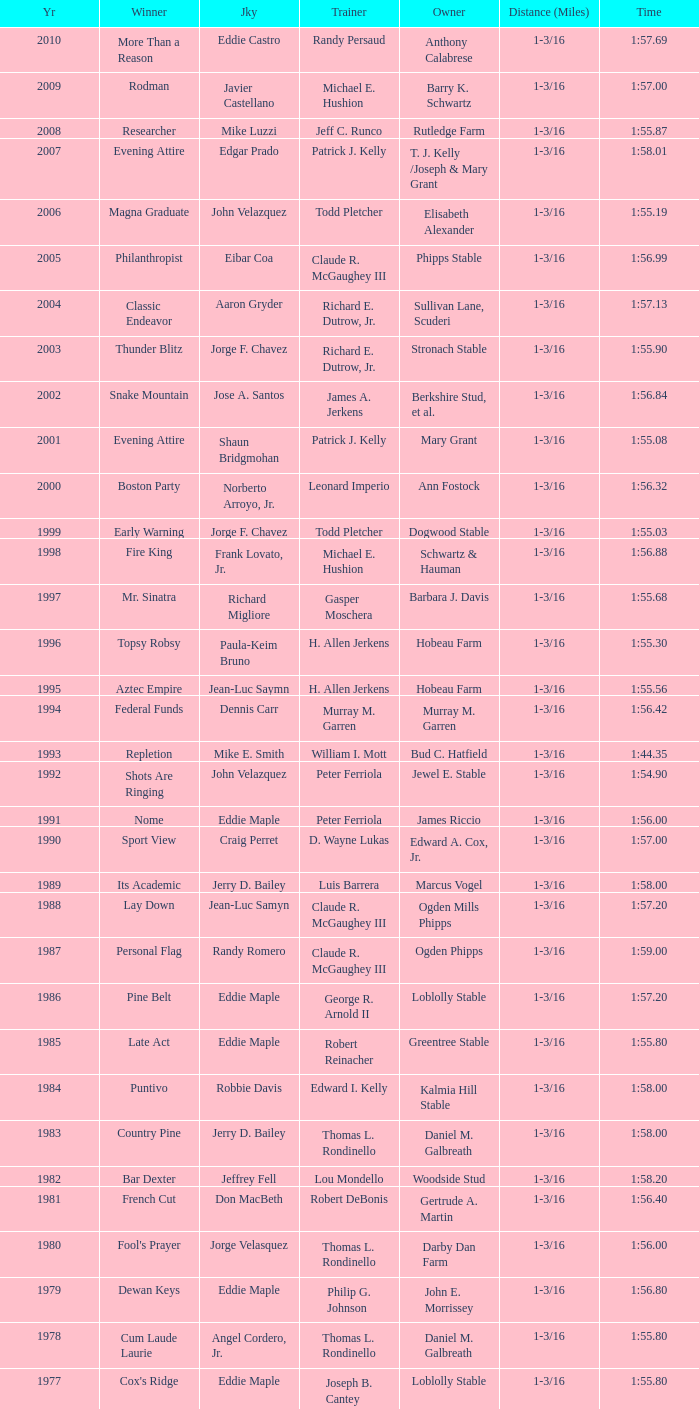What horse won with a trainer of "no race"? No Race, No Race, No Race, No Race. 